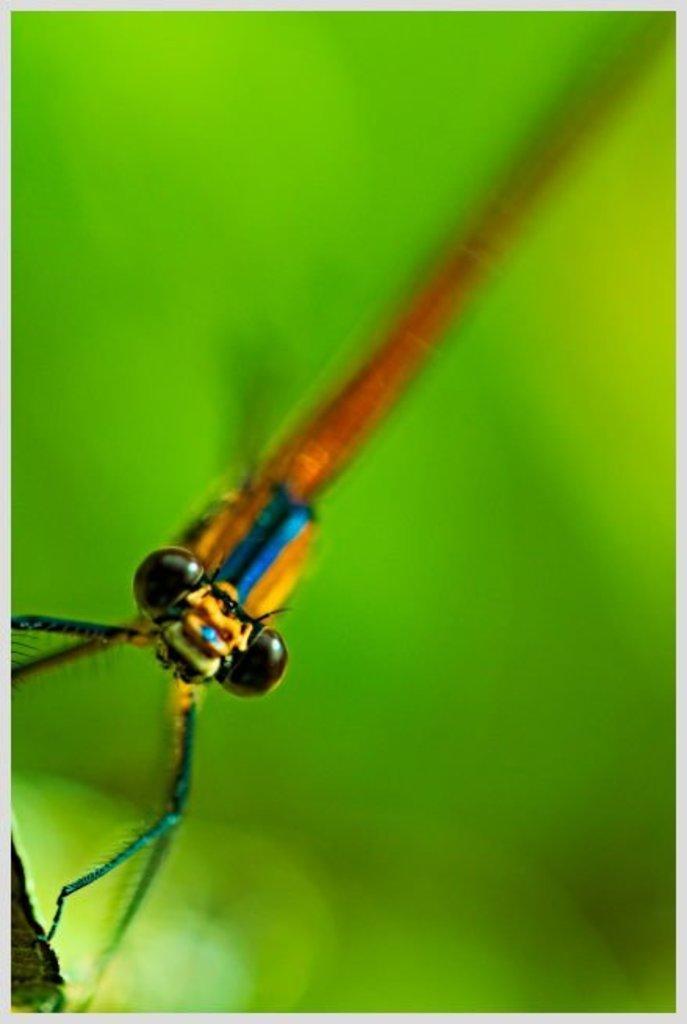Could you give a brief overview of what you see in this image? In this picture we can see an insect in the front, it looks like a leaf in the background, there is a blurry background. 